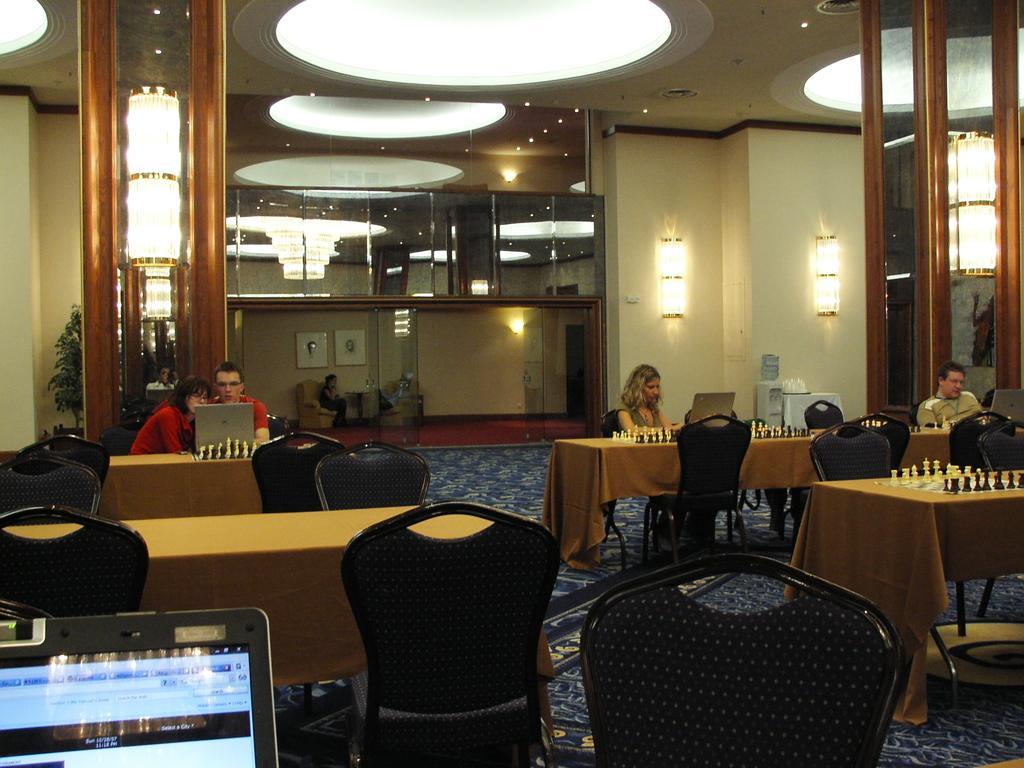Please provide a concise description of this image. Bottom left side of the image there are some tables and chairs and two persons sitting on chairs and looking in to a laptop. Bottom right side of the image there are some tables and chairs on the tables there are some chess boards and there are two persons sitting and looking in to laptops. Behind them there is a wall on the wall there are two lights. Top of the image there is a roof and lights. In the middle of the image there is a chair on the chair there is a person sitting. Top left side of the image there is a plant. 